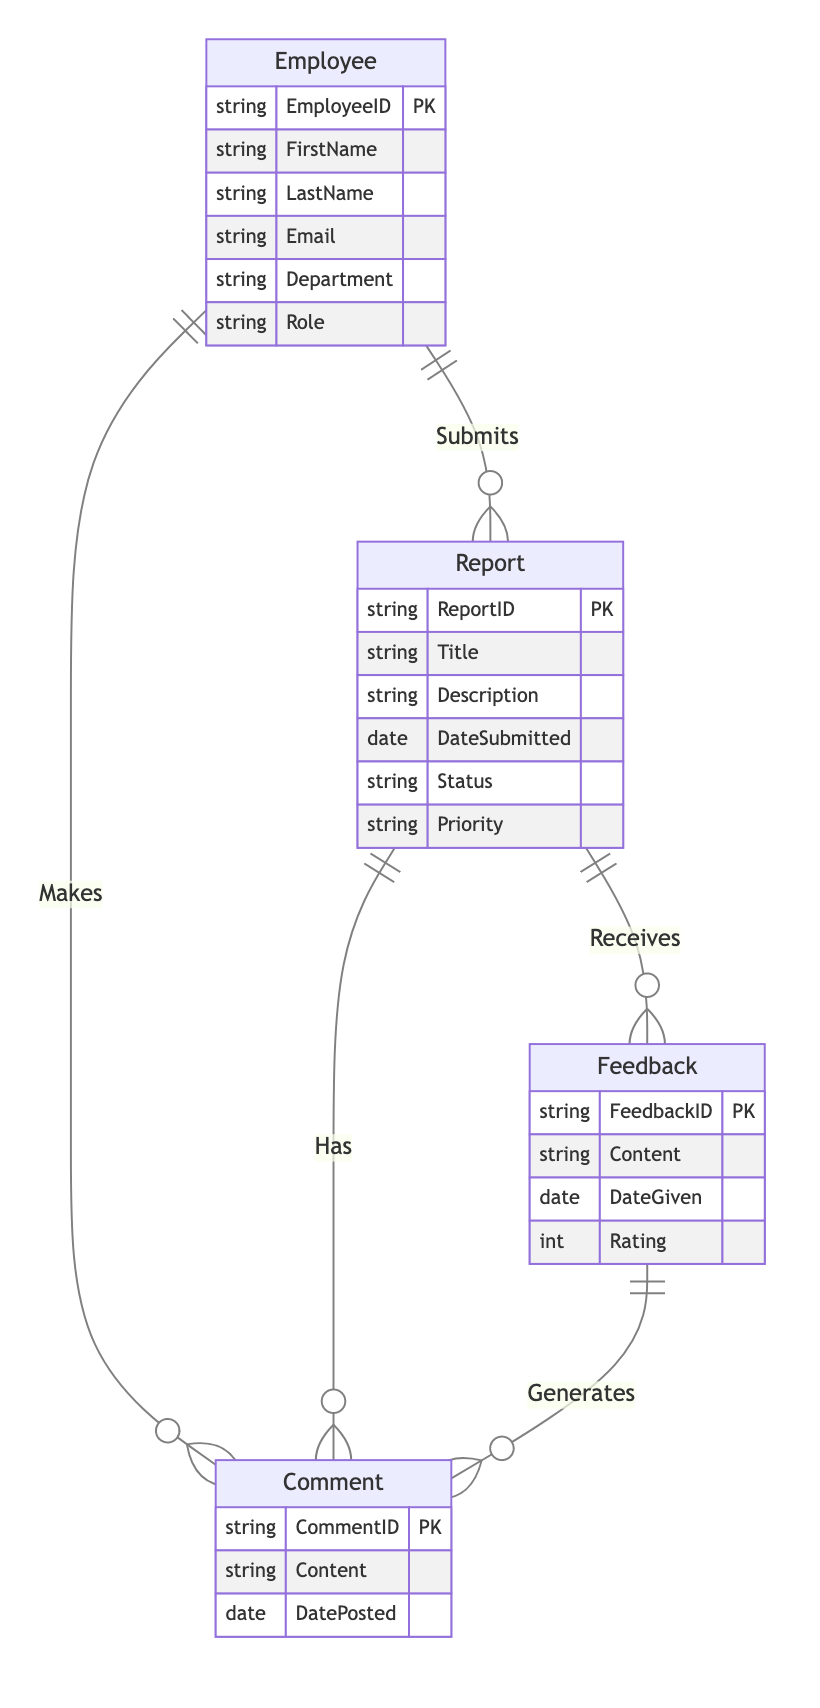What is the primary key of the Employee entity? The primary key for the Employee entity is designated as EmployeeID. This is indicated in the diagram where the attribute EmployeeID is labeled as "PK", signifying it as the primary key for that entity.
Answer: EmployeeID How many attributes does the Report entity have? The attributes listed for the Report entity include ReportID, Title, Description, DateSubmitted, Status, and Priority. Counting these attributes results in a total of six attributes for the Report entity.
Answer: 6 What relationship connects Employee and Report? The relationship connecting Employee and Report is named "Submits". It is a one-to-many relationship, indicating that one employee can submit multiple reports. This information is clearly indicated by the line and notation in the diagram.
Answer: Submits How many feedback instances can a report receive? A report can receive multiple feedback instances, as indicated by the one-to-many relationship "Receives" between Report and Feedback. This means that for one report, there can be many feedback entries associated with it.
Answer: Many What does the Comment entity generate? The Feedback entity generates comments, as shown in the one-to-many relationship labeled "Generates" between Feedback and Comment. This relationship indicates that each feedback can produce multiple comments.
Answer: Comments What is the total number of entities in the diagram? The total number of entities represented in the diagram includes Employee, Report, Feedback, and Comment, leading to a count of four distinct entities within the diagram.
Answer: 4 Which entity can make comments? The entity that can make comments is the Employee, as indicated by the one-to-many relationship labeled "Makes" between Employee and Comment. This shows that an employee can create multiple comments.
Answer: Employee What is the primary key of the Feedback entity? The primary key for the Feedback entity is labeled as FeedbackID in the diagram. It is marked as "PK", indicating that this attribute uniquely identifies each feedback entry within the entity.
Answer: FeedbackID How many relationships connect Report to other entities? The Report entity connects to three other entities through relationships: it "Receives" Feedback, "Has" Comments, and is "Submitted" by Employee. Counting these connections provides a total of three relationships associated with the Report entity.
Answer: 3 